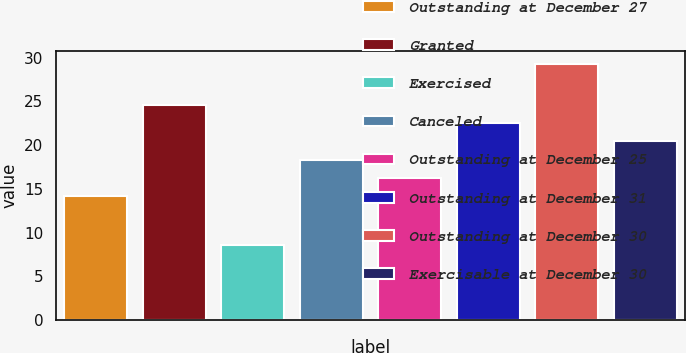Convert chart. <chart><loc_0><loc_0><loc_500><loc_500><bar_chart><fcel>Outstanding at December 27<fcel>Granted<fcel>Exercised<fcel>Canceled<fcel>Outstanding at December 25<fcel>Outstanding at December 31<fcel>Outstanding at December 30<fcel>Exercisable at December 30<nl><fcel>14.21<fcel>24.56<fcel>8.56<fcel>18.35<fcel>16.28<fcel>22.49<fcel>29.24<fcel>20.42<nl></chart> 